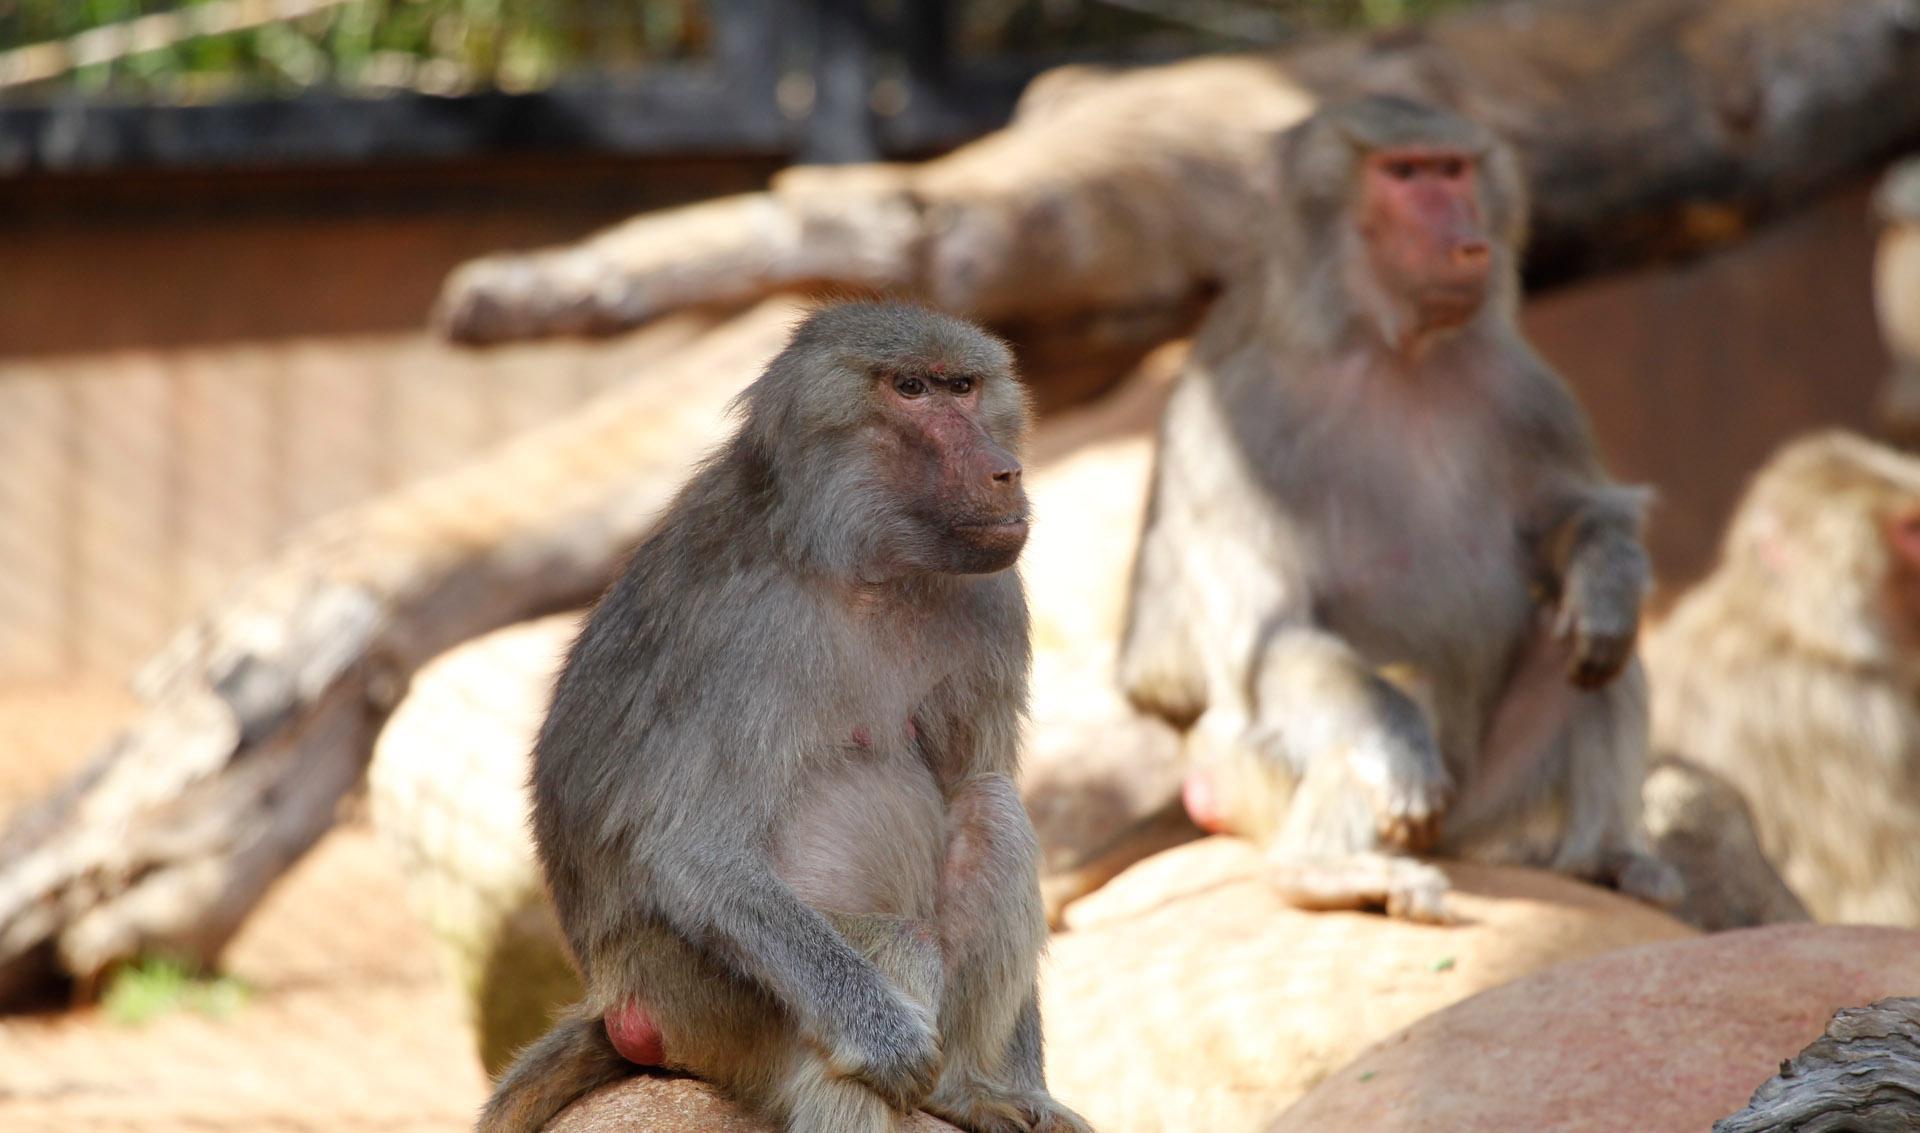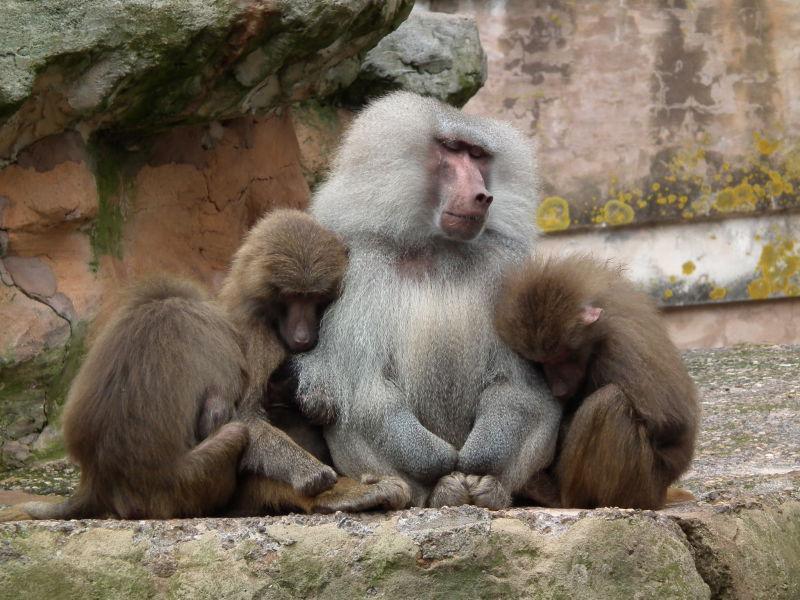The first image is the image on the left, the second image is the image on the right. For the images displayed, is the sentence "Exactly two baboons are in the foreground in at least one image." factually correct? Answer yes or no. Yes. 